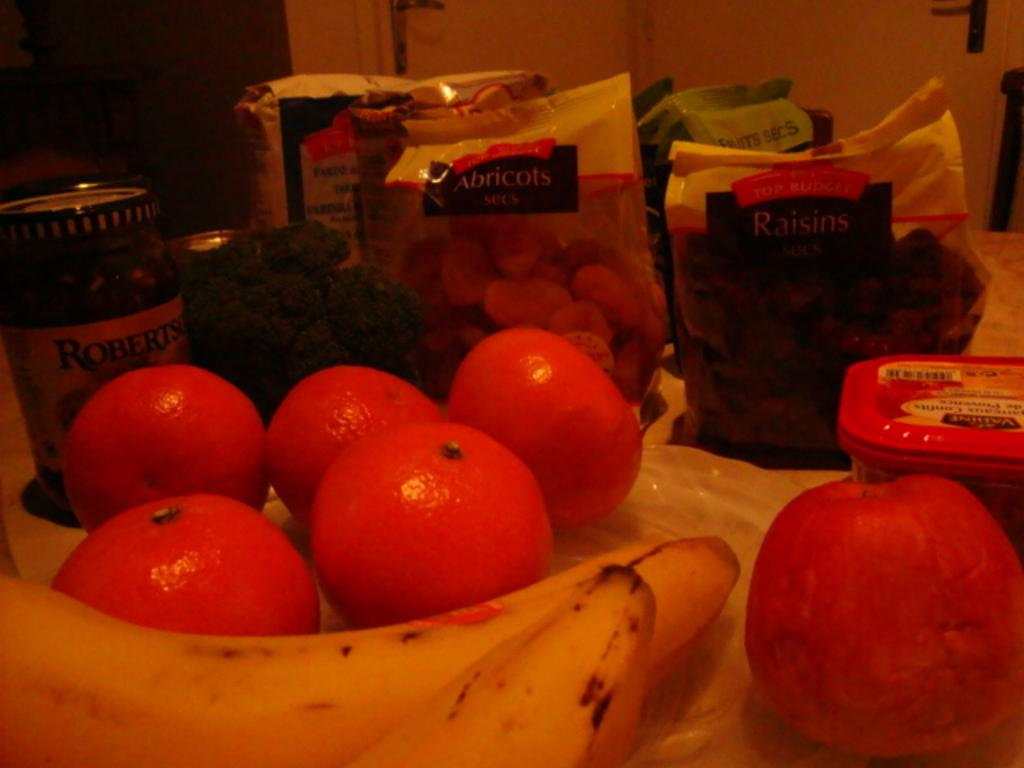What type of food items can be seen on the table in the image? There are fruits on the table in the image. What other items can be seen on the table besides fruits? There are tins, a box, and packets on the table. What is visible in the background of the image? There is a wall visible in the image. Can you see the mother playing with her child at the seashore in the image? There is no seashore or mother with a child present in the image; it features a table with various items on it and a wall in the background. 